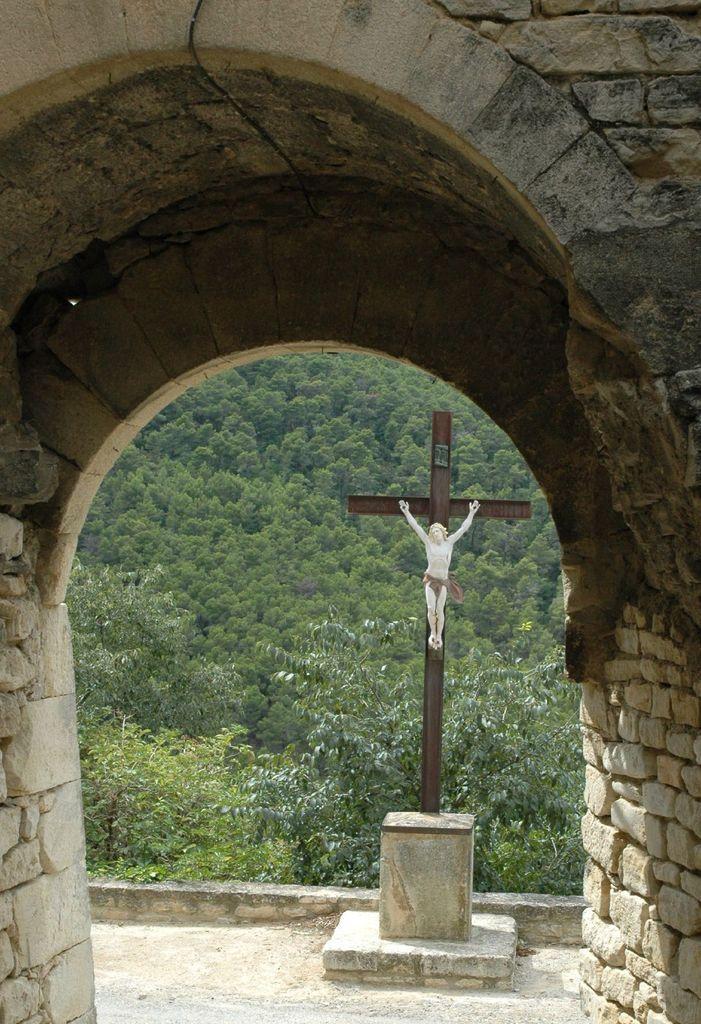In one or two sentences, can you explain what this image depicts? In this image we can see an arch. In the background there is a statue and trees. 